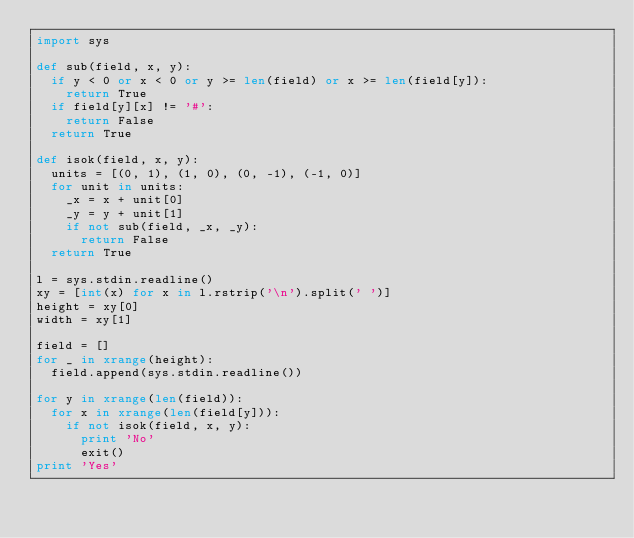Convert code to text. <code><loc_0><loc_0><loc_500><loc_500><_Python_>import sys

def sub(field, x, y):
  if y < 0 or x < 0 or y >= len(field) or x >= len(field[y]):
    return True
  if field[y][x] != '#':
    return False
  return True

def isok(field, x, y):
  units = [(0, 1), (1, 0), (0, -1), (-1, 0)]
  for unit in units:
    _x = x + unit[0]
    _y = y + unit[1]
    if not sub(field, _x, _y):
      return False
  return True

l = sys.stdin.readline()
xy = [int(x) for x in l.rstrip('\n').split(' ')]
height = xy[0]
width = xy[1]

field = []
for _ in xrange(height):
  field.append(sys.stdin.readline())

for y in xrange(len(field)):
  for x in xrange(len(field[y])):
    if not isok(field, x, y):
      print 'No'
      exit()
print 'Yes'</code> 